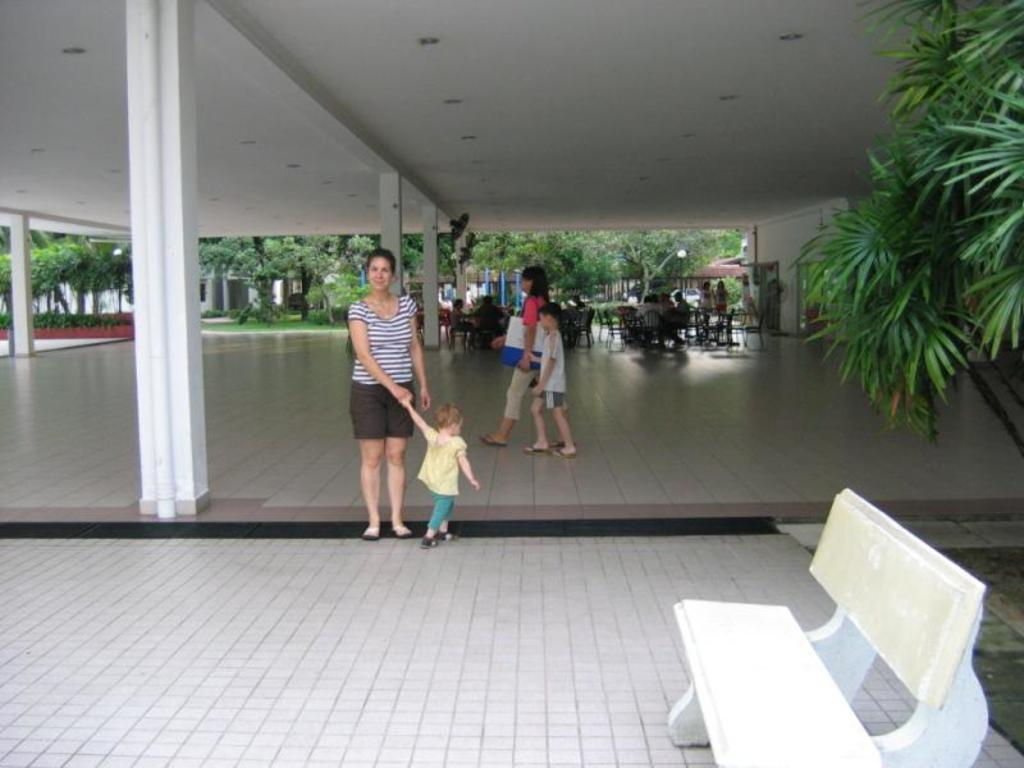What type of furniture can be seen in the image? There is a chair in the image, and there are also tables and chairs. Can you describe the people in the image? The image contains people, but their specific actions or appearances are not mentioned in the provided facts. What type of natural environment is visible in the image? There is grass and trees visible in the image. What type of flesh can be seen on the horn of the appliance in the image? There is no flesh, horn, or appliance present in the image. 